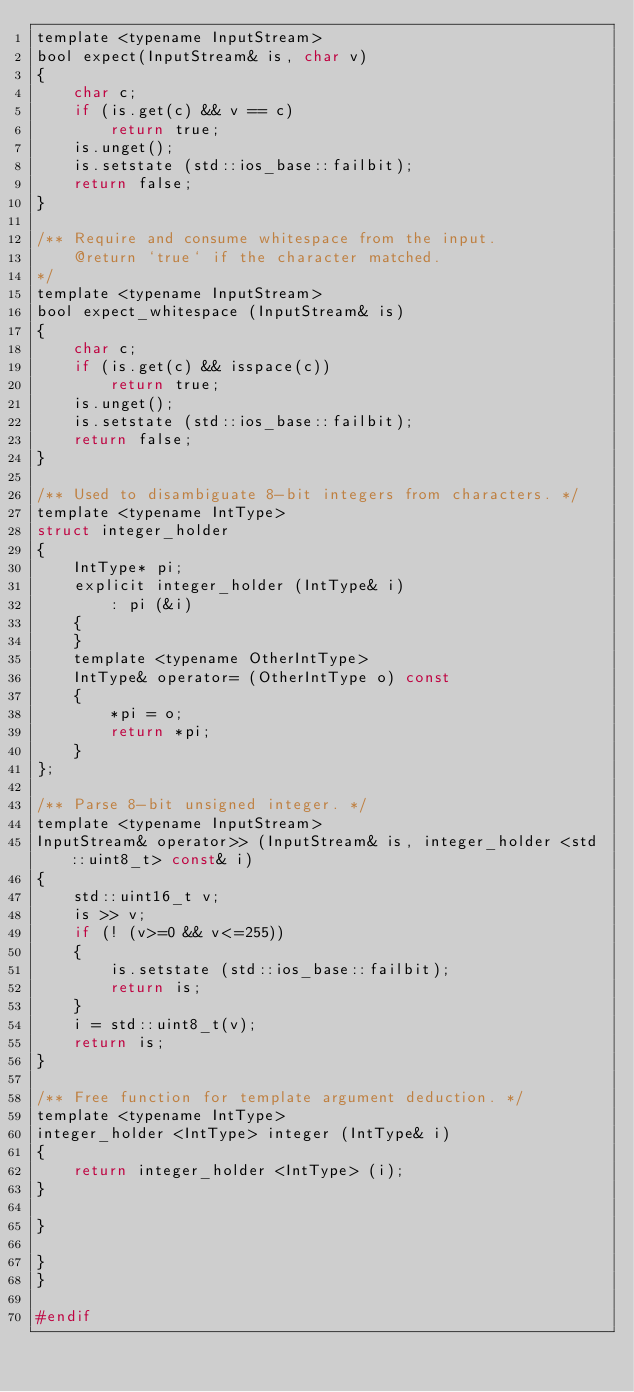<code> <loc_0><loc_0><loc_500><loc_500><_C_>template <typename InputStream>
bool expect(InputStream& is, char v)
{
    char c;
    if (is.get(c) && v == c)
        return true;
    is.unget();
    is.setstate (std::ios_base::failbit);
    return false;
}

/** Require and consume whitespace from the input.
    @return `true` if the character matched.
*/
template <typename InputStream>
bool expect_whitespace (InputStream& is)
{
    char c;
    if (is.get(c) && isspace(c))
        return true;
    is.unget();
    is.setstate (std::ios_base::failbit);
    return false;
}

/** Used to disambiguate 8-bit integers from characters. */
template <typename IntType>
struct integer_holder
{
    IntType* pi;
    explicit integer_holder (IntType& i)
        : pi (&i)
    {
    }
    template <typename OtherIntType>
    IntType& operator= (OtherIntType o) const
    {
        *pi = o;
        return *pi;
    }
};

/** Parse 8-bit unsigned integer. */
template <typename InputStream>
InputStream& operator>> (InputStream& is, integer_holder <std::uint8_t> const& i)
{
    std::uint16_t v;
    is >> v;
    if (! (v>=0 && v<=255))
    {
        is.setstate (std::ios_base::failbit);
        return is;
    }
    i = std::uint8_t(v);
    return is;
}

/** Free function for template argument deduction. */
template <typename IntType>
integer_holder <IntType> integer (IntType& i)
{
    return integer_holder <IntType> (i);
}

}

}
}

#endif
</code> 